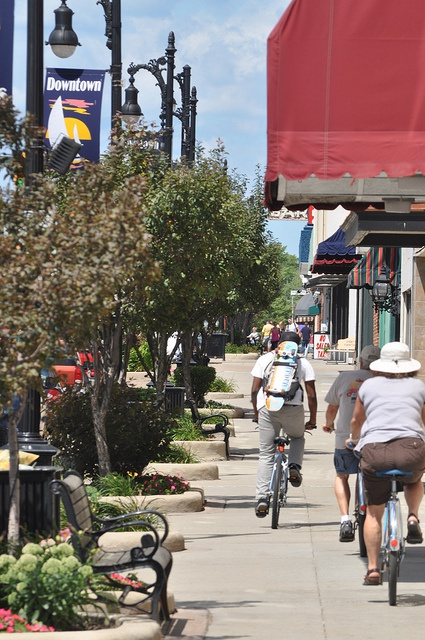Describe the objects in this image and their specific colors. I can see people in navy, lightgray, gray, and black tones, potted plant in navy, black, olive, darkgreen, and gray tones, bench in navy, black, gray, darkgray, and darkgreen tones, people in navy, gray, white, darkgray, and black tones, and people in navy, gray, and lightgray tones in this image. 